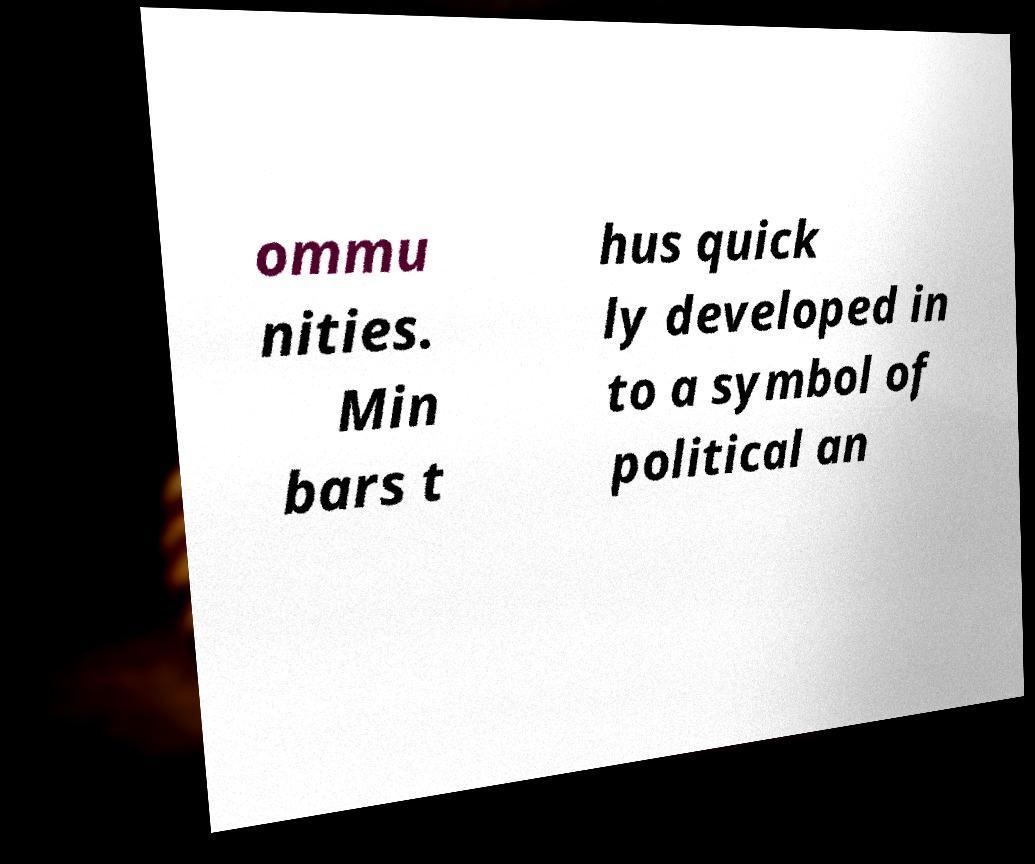Please read and relay the text visible in this image. What does it say? ommu nities. Min bars t hus quick ly developed in to a symbol of political an 